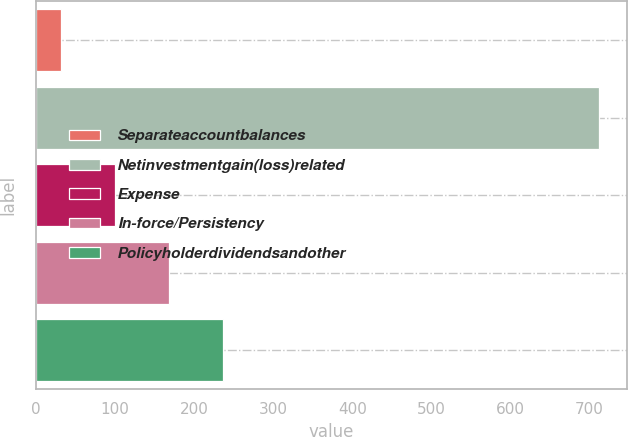<chart> <loc_0><loc_0><loc_500><loc_500><bar_chart><fcel>Separateaccountbalances<fcel>Netinvestmentgain(loss)related<fcel>Expense<fcel>In-force/Persistency<fcel>Policyholderdividendsandother<nl><fcel>32<fcel>712<fcel>100<fcel>168<fcel>236<nl></chart> 